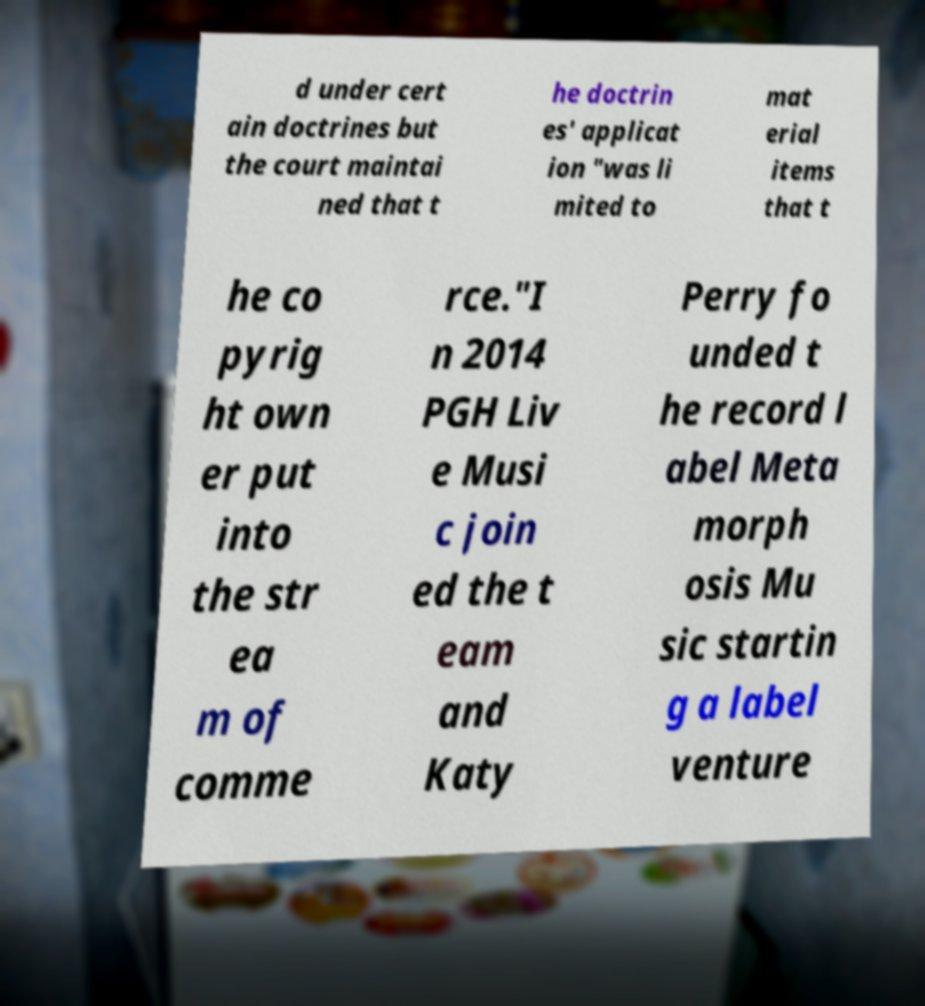Please identify and transcribe the text found in this image. d under cert ain doctrines but the court maintai ned that t he doctrin es' applicat ion "was li mited to mat erial items that t he co pyrig ht own er put into the str ea m of comme rce."I n 2014 PGH Liv e Musi c join ed the t eam and Katy Perry fo unded t he record l abel Meta morph osis Mu sic startin g a label venture 